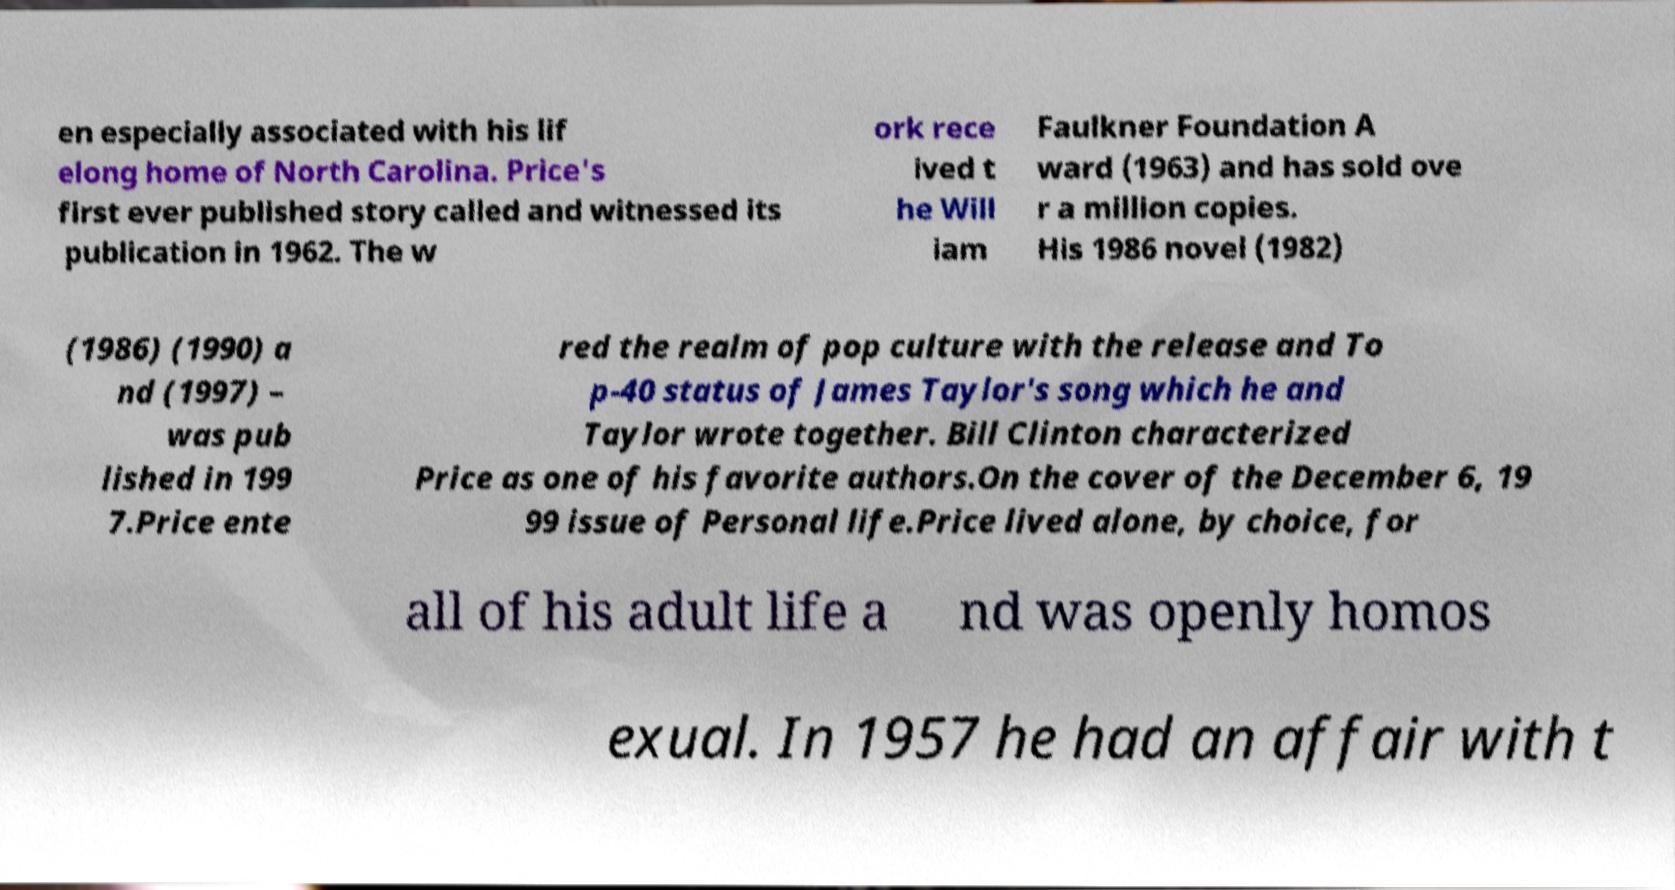Could you assist in decoding the text presented in this image and type it out clearly? en especially associated with his lif elong home of North Carolina. Price's first ever published story called and witnessed its publication in 1962. The w ork rece ived t he Will iam Faulkner Foundation A ward (1963) and has sold ove r a million copies. His 1986 novel (1982) (1986) (1990) a nd (1997) – was pub lished in 199 7.Price ente red the realm of pop culture with the release and To p-40 status of James Taylor's song which he and Taylor wrote together. Bill Clinton characterized Price as one of his favorite authors.On the cover of the December 6, 19 99 issue of Personal life.Price lived alone, by choice, for all of his adult life a nd was openly homos exual. In 1957 he had an affair with t 